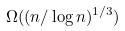<formula> <loc_0><loc_0><loc_500><loc_500>\Omega ( ( n / \log n ) ^ { 1 / 3 } )</formula> 